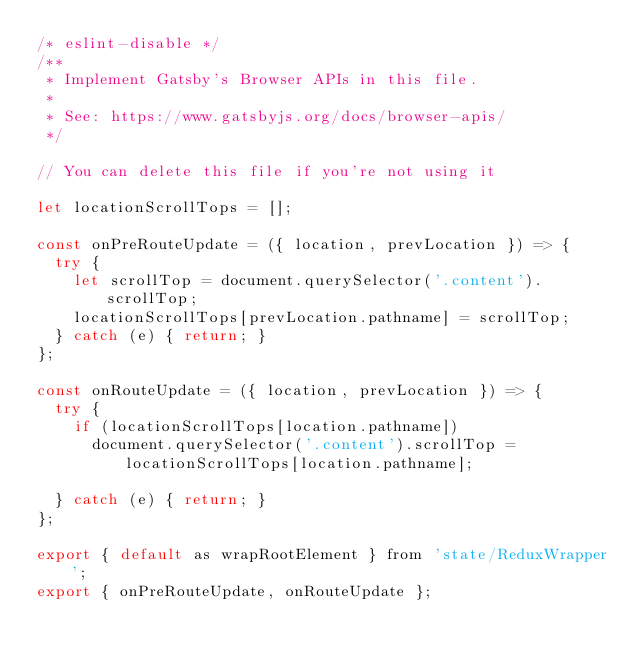<code> <loc_0><loc_0><loc_500><loc_500><_JavaScript_>/* eslint-disable */
/**
 * Implement Gatsby's Browser APIs in this file.
 *
 * See: https://www.gatsbyjs.org/docs/browser-apis/
 */

// You can delete this file if you're not using it

let locationScrollTops = [];

const onPreRouteUpdate = ({ location, prevLocation }) => {
  try {
    let scrollTop = document.querySelector('.content').scrollTop;
    locationScrollTops[prevLocation.pathname] = scrollTop;
  } catch (e) { return; }
};

const onRouteUpdate = ({ location, prevLocation }) => {
  try {
    if (locationScrollTops[location.pathname])
      document.querySelector('.content').scrollTop = locationScrollTops[location.pathname];

  } catch (e) { return; }
};

export { default as wrapRootElement } from 'state/ReduxWrapper';
export { onPreRouteUpdate, onRouteUpdate };
</code> 